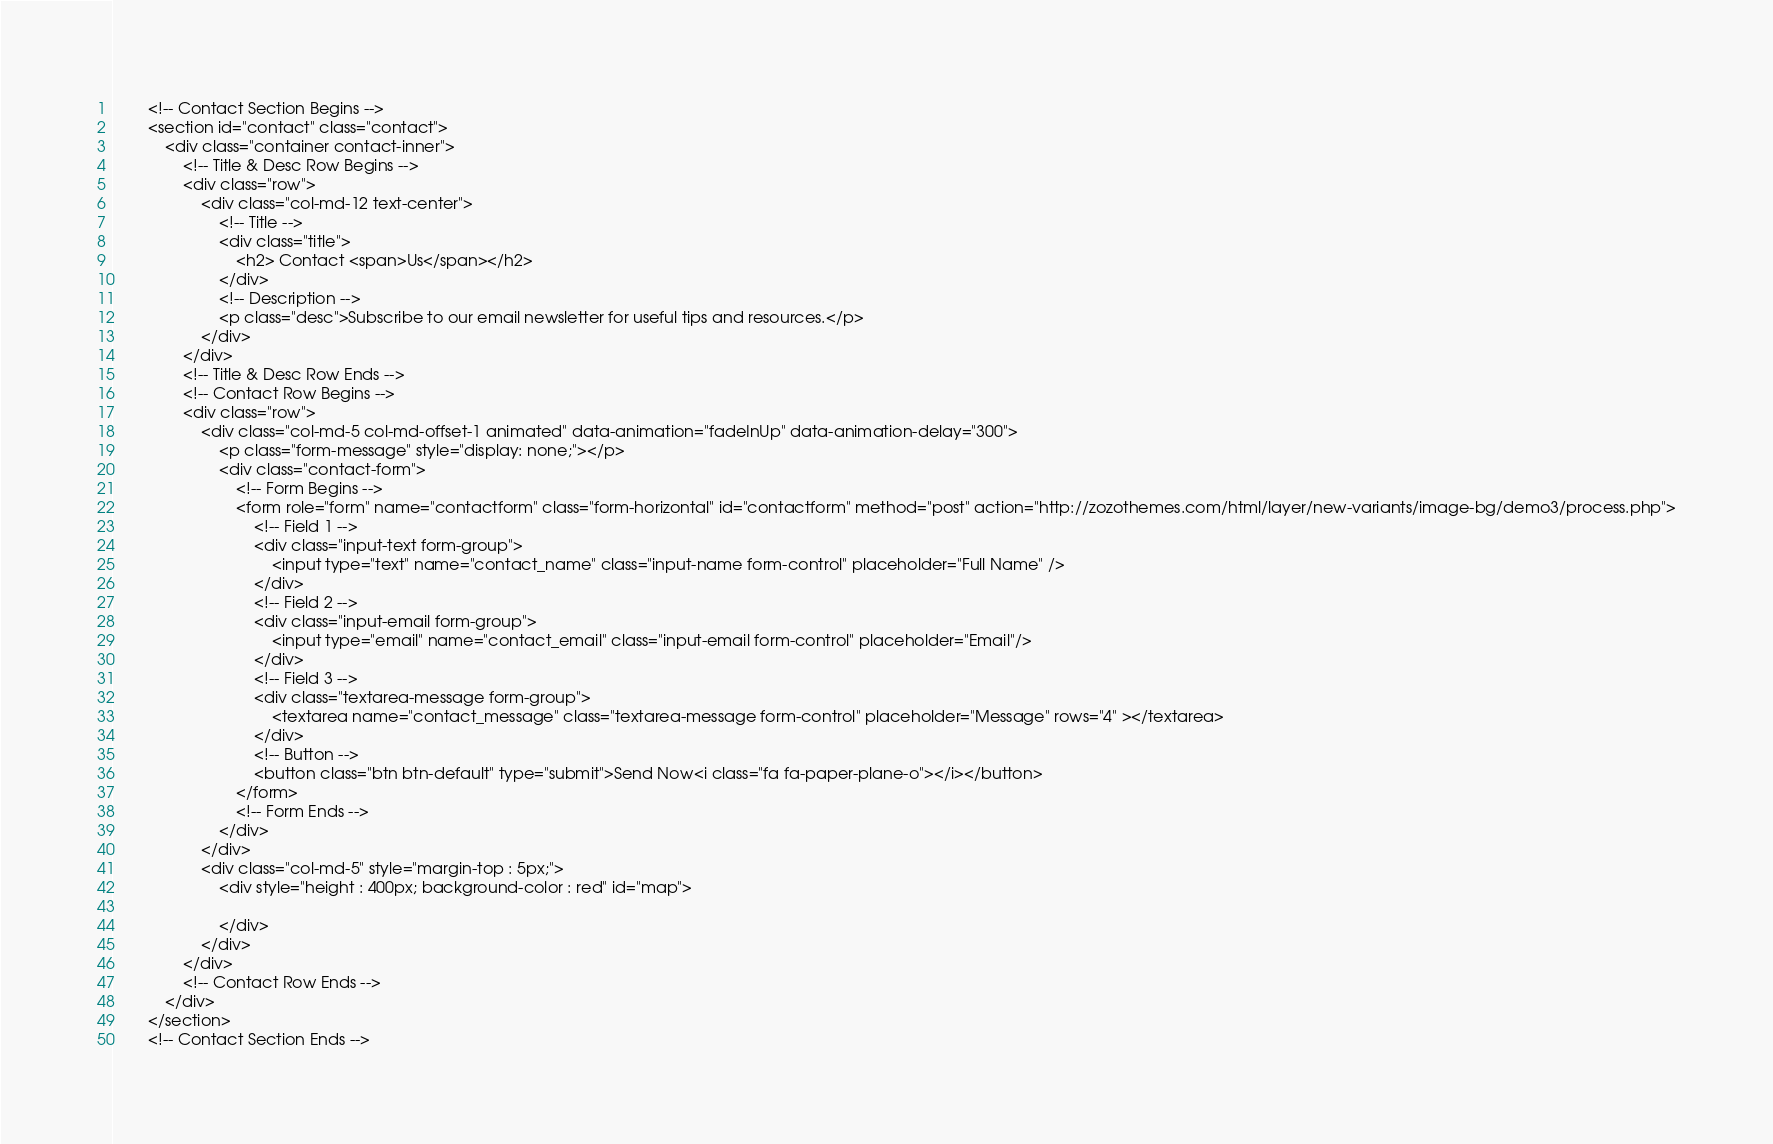Convert code to text. <code><loc_0><loc_0><loc_500><loc_500><_PHP_>        <!-- Contact Section Begins -->
        <section id="contact" class="contact">
            <div class="container contact-inner">
                <!-- Title & Desc Row Begins -->
                <div class="row">
                    <div class="col-md-12 text-center">
                        <!-- Title --> 
                        <div class="title">
                            <h2> Contact <span>Us</span></h2>
                        </div>
                        <!-- Description --> 
                        <p class="desc">Subscribe to our email newsletter for useful tips and resources.</p>
                    </div>
                </div>
                <!-- Title & Desc Row Ends -->
                <!-- Contact Row Begins -->
                <div class="row">
                    <div class="col-md-5 col-md-offset-1 animated" data-animation="fadeInUp" data-animation-delay="300">
                        <p class="form-message" style="display: none;"></p>
                        <div class="contact-form">
                            <!-- Form Begins -->
                            <form role="form" name="contactform" class="form-horizontal" id="contactform" method="post" action="http://zozothemes.com/html/layer/new-variants/image-bg/demo3/process.php">
                                <!-- Field 1 -->		
                                <div class="input-text form-group">
                                    <input type="text" name="contact_name" class="input-name form-control" placeholder="Full Name" />
                                </div>
                                <!-- Field 2 -->
                                <div class="input-email form-group">
                                    <input type="email" name="contact_email" class="input-email form-control" placeholder="Email"/>
                                </div>
                                <!-- Field 3 -->
                                <div class="textarea-message form-group">
                                    <textarea name="contact_message" class="textarea-message form-control" placeholder="Message" rows="4" ></textarea>
                                </div>
                                <!-- Button -->
                                <button class="btn btn-default" type="submit">Send Now<i class="fa fa-paper-plane-o"></i></button>			
                            </form>
                            <!-- Form Ends -->
                        </div>
                    </div>
                    <div class="col-md-5" style="margin-top : 5px;">
                        <div style="height : 400px; background-color : red" id="map">
                            
                        </div>
                    </div>
                </div>
                <!-- Contact Row Ends -->
            </div>
        </section>
        <!-- Contact Section Ends --></code> 